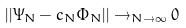<formula> <loc_0><loc_0><loc_500><loc_500>| | \Psi _ { N } - c _ { N } \Phi _ { N } | | \rightarrow _ { N \rightarrow \infty } 0</formula> 